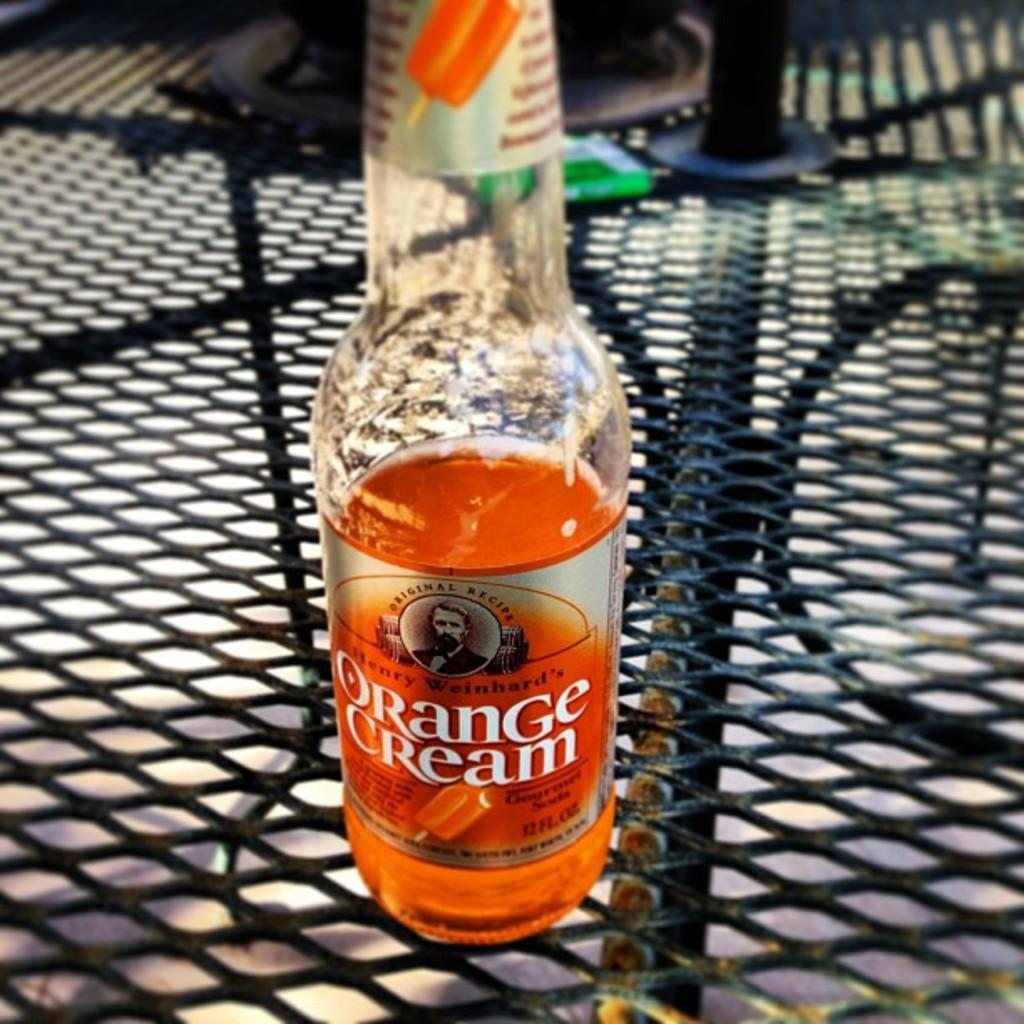Provide a one-sentence caption for the provided image. A glass bottle half full of Orange Cream soda from Henry Weinhard. 